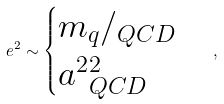<formula> <loc_0><loc_0><loc_500><loc_500>\ e ^ { 2 } \sim \begin{cases} m _ { q } / \L _ { Q C D } \\ a ^ { 2 } \L _ { Q C D } ^ { 2 } \end{cases} ,</formula> 